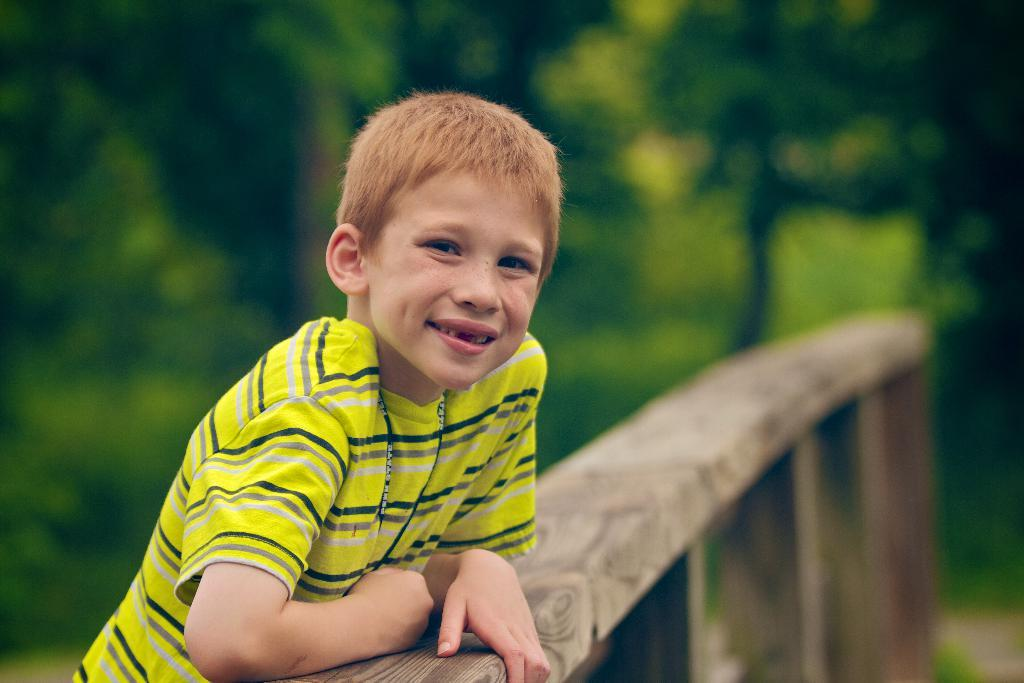What is the main subject of the image? There is a man standing in the middle of the image. What is the man holding in the image? The man is holding a wood pillar. What can be seen behind the man in the image? There is a green background visible in the image. What type of medical advice is the doctor giving to the man in the image? There is no doctor present in the image, so no medical advice can be given. 